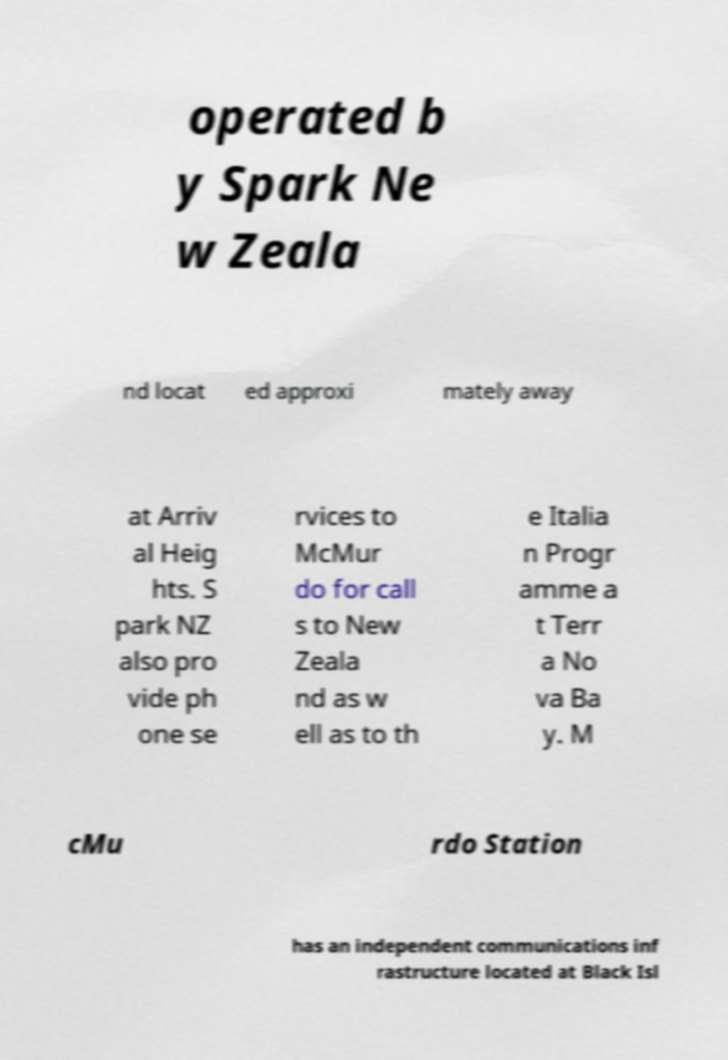Please read and relay the text visible in this image. What does it say? operated b y Spark Ne w Zeala nd locat ed approxi mately away at Arriv al Heig hts. S park NZ also pro vide ph one se rvices to McMur do for call s to New Zeala nd as w ell as to th e Italia n Progr amme a t Terr a No va Ba y. M cMu rdo Station has an independent communications inf rastructure located at Black Isl 